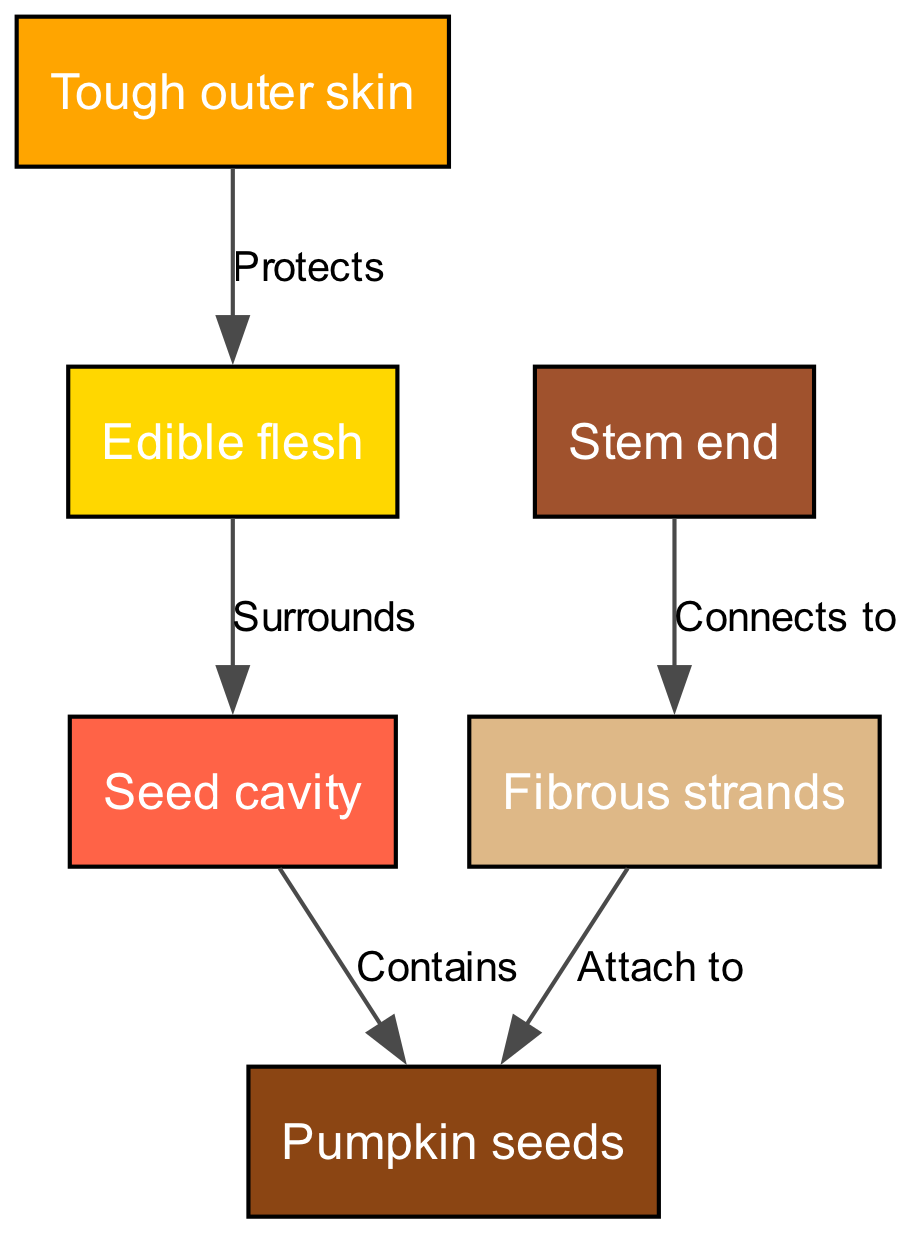What is the outer layer of the pumpkin called? The diagram indicates that the outer layer of the pumpkin is labeled "Tough outer skin," which serves as a protective barrier.
Answer: Tough outer skin How many main internal structures are there in the pumpkin? The diagram lists five primary internal structures: tough outer skin, edible flesh, seed cavity, pumpkin seeds, and fibrous strands. Thus, the total is five.
Answer: 5 Which part connects to the fibrous strands? The diagram shows that the "Stem end" connects to the "Fibrous strands," indicating the source from which these strands extend.
Answer: Stem end What structure surrounds the seed cavity? The diagram indicates that the "Edible flesh" surrounds the "Seed cavity," highlighting which part encapsulates it.
Answer: Edible flesh What do the fibrous strands do in relation to the seeds? According to the diagram, the "Fibrous strands" attach to the "Pumpkin seeds," indicating their relationship and function concerning the seeds.
Answer: Attach to Which internal structure contains the seeds? The diagram specifies that the "Seed cavity" contains the "Pumpkin seeds," making it clear where the seeds are located within the pumpkin.
Answer: Seed cavity What relationship exists between the tough outer skin and the edible flesh? The diagram describes the relationship where the "Tough outer skin" protects the "Edible flesh," indicating a protective function.
Answer: Protects If the seed cavity is removed, which part would remain surrounding the flesh? Based on the diagram, if the "Seed cavity" is removed, the "Edible flesh" would still remain as it is the part that surrounds the cavity.
Answer: Edible flesh What is the purpose of the stem end in the pumpkin's structure? The diagram illustrates that the "Stem end" connects to the "Fibrous strands," suggesting its role in linking the pumpkin’s body with the fibrous structures that may aid in seed nourishment.
Answer: Connects to 